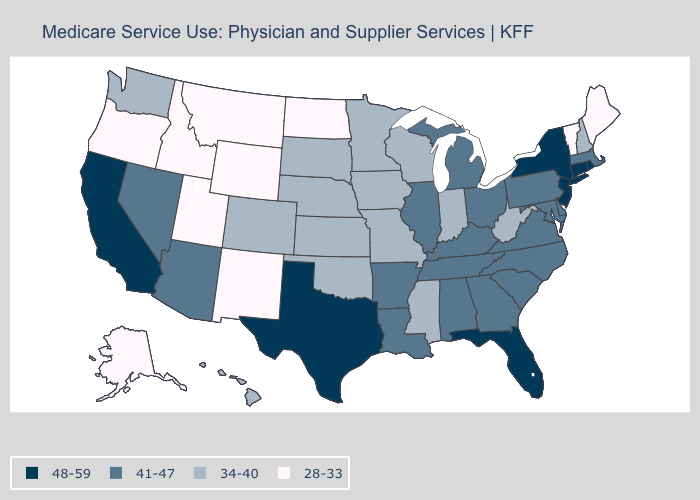What is the value of Nevada?
Keep it brief. 41-47. Does Florida have a higher value than California?
Write a very short answer. No. Name the states that have a value in the range 41-47?
Be succinct. Alabama, Arizona, Arkansas, Delaware, Georgia, Illinois, Kentucky, Louisiana, Maryland, Massachusetts, Michigan, Nevada, North Carolina, Ohio, Pennsylvania, South Carolina, Tennessee, Virginia. How many symbols are there in the legend?
Write a very short answer. 4. What is the value of Alaska?
Answer briefly. 28-33. How many symbols are there in the legend?
Answer briefly. 4. Name the states that have a value in the range 41-47?
Keep it brief. Alabama, Arizona, Arkansas, Delaware, Georgia, Illinois, Kentucky, Louisiana, Maryland, Massachusetts, Michigan, Nevada, North Carolina, Ohio, Pennsylvania, South Carolina, Tennessee, Virginia. What is the value of Hawaii?
Concise answer only. 34-40. Does Oregon have the lowest value in the USA?
Keep it brief. Yes. Does Wyoming have the highest value in the USA?
Short answer required. No. What is the value of Virginia?
Keep it brief. 41-47. Which states have the highest value in the USA?
Answer briefly. California, Connecticut, Florida, New Jersey, New York, Rhode Island, Texas. Which states hav the highest value in the West?
Quick response, please. California. What is the highest value in the USA?
Quick response, please. 48-59. Name the states that have a value in the range 28-33?
Short answer required. Alaska, Idaho, Maine, Montana, New Mexico, North Dakota, Oregon, Utah, Vermont, Wyoming. 